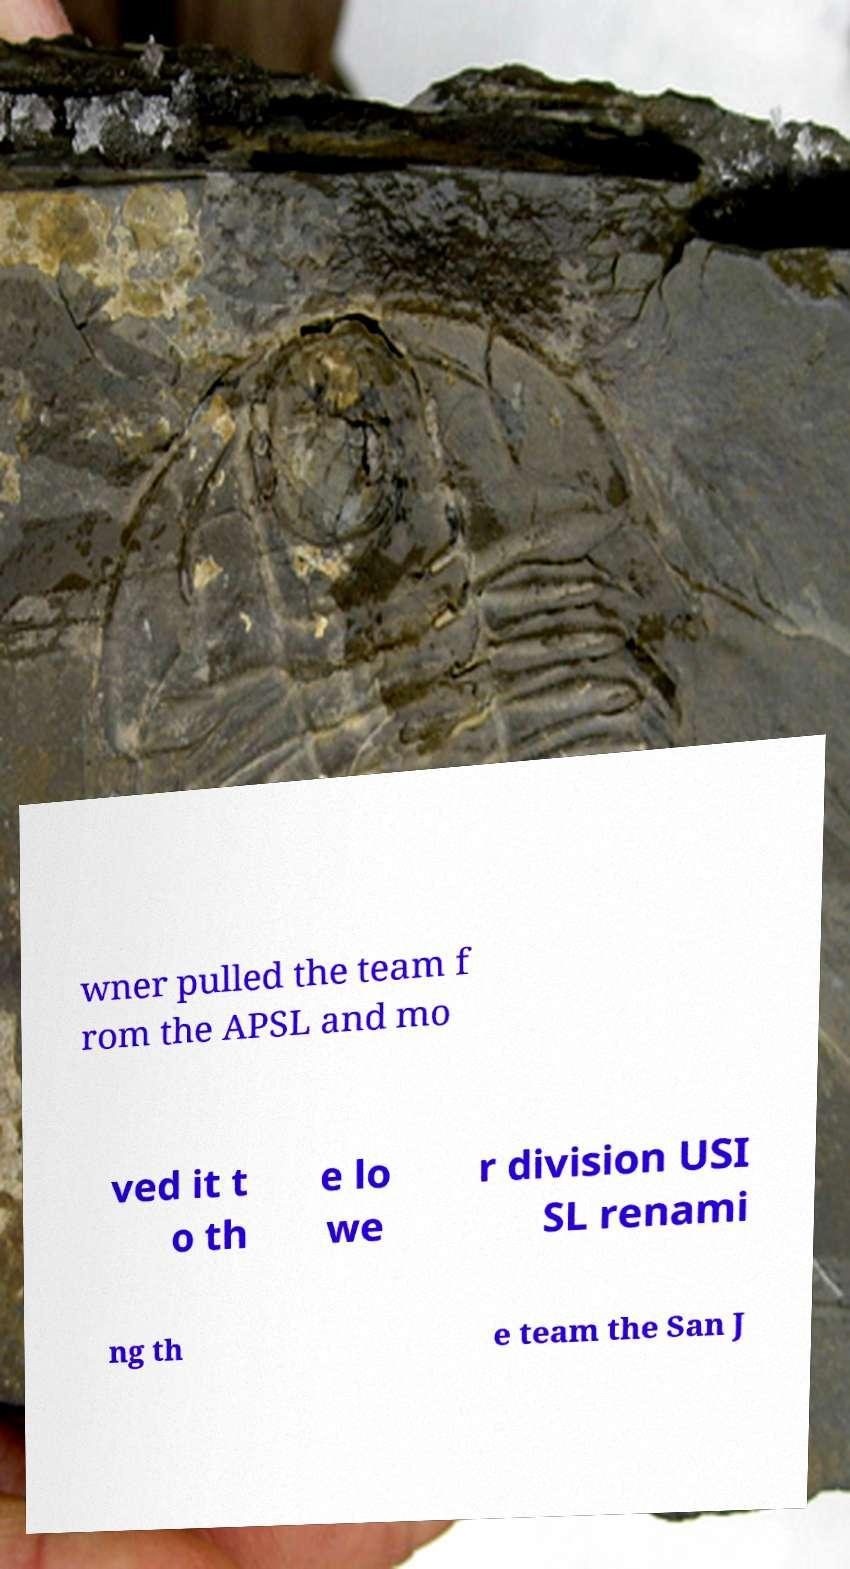For documentation purposes, I need the text within this image transcribed. Could you provide that? wner pulled the team f rom the APSL and mo ved it t o th e lo we r division USI SL renami ng th e team the San J 